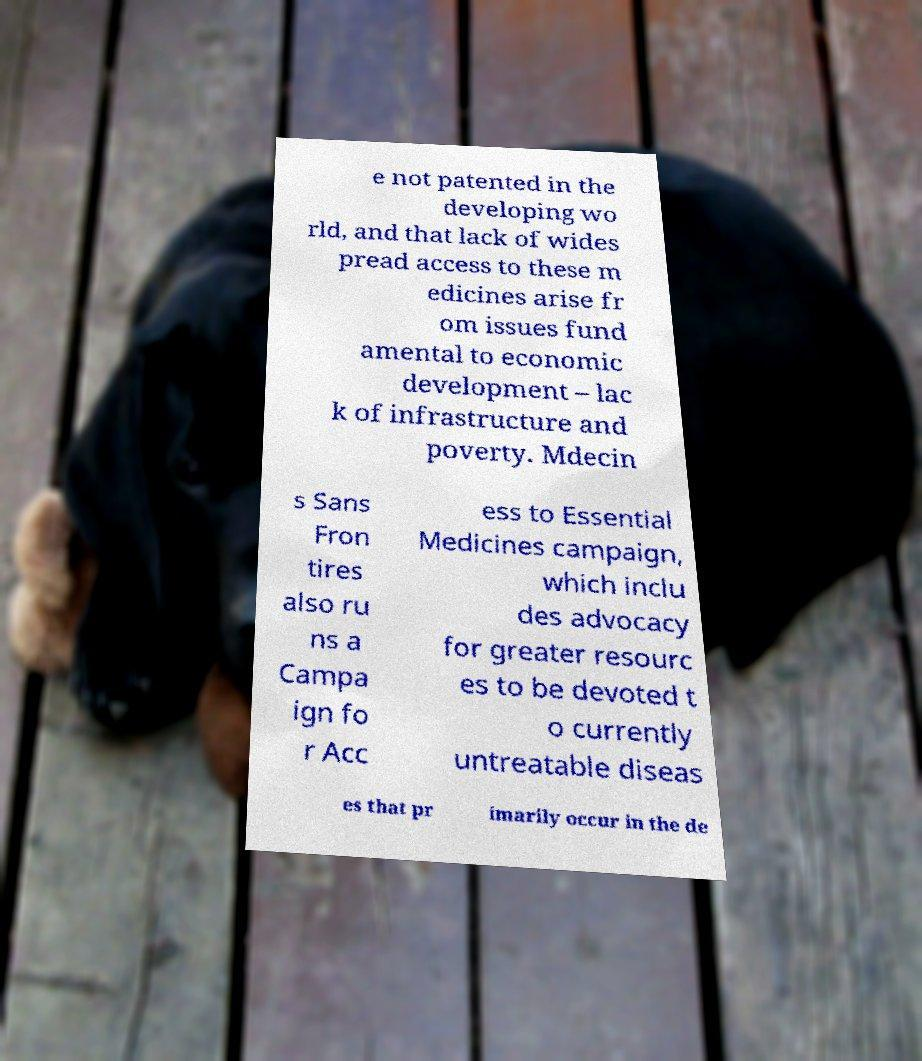Could you assist in decoding the text presented in this image and type it out clearly? e not patented in the developing wo rld, and that lack of wides pread access to these m edicines arise fr om issues fund amental to economic development – lac k of infrastructure and poverty. Mdecin s Sans Fron tires also ru ns a Campa ign fo r Acc ess to Essential Medicines campaign, which inclu des advocacy for greater resourc es to be devoted t o currently untreatable diseas es that pr imarily occur in the de 